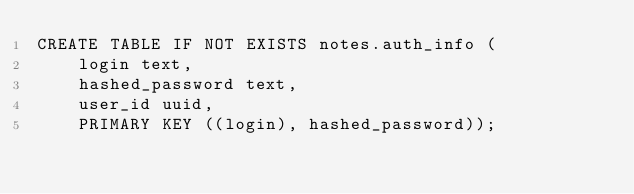<code> <loc_0><loc_0><loc_500><loc_500><_SQL_>CREATE TABLE IF NOT EXISTS notes.auth_info (
    login text,
    hashed_password text,
    user_id uuid,
    PRIMARY KEY ((login), hashed_password));
</code> 